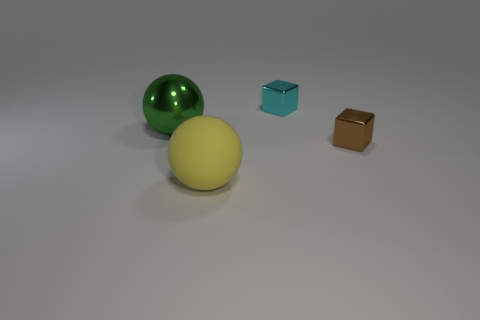Add 1 tiny yellow shiny cubes. How many objects exist? 5 Add 4 small brown objects. How many small brown objects are left? 5 Add 4 large cyan spheres. How many large cyan spheres exist? 4 Subtract 0 blue spheres. How many objects are left? 4 Subtract all big purple balls. Subtract all tiny brown cubes. How many objects are left? 3 